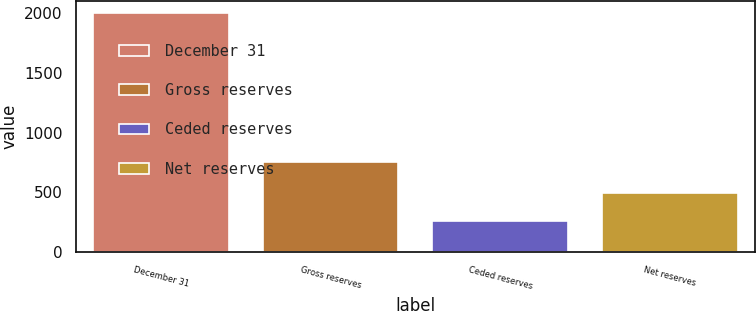Convert chart. <chart><loc_0><loc_0><loc_500><loc_500><bar_chart><fcel>December 31<fcel>Gross reserves<fcel>Ceded reserves<fcel>Net reserves<nl><fcel>2004<fcel>755<fcel>258<fcel>497<nl></chart> 